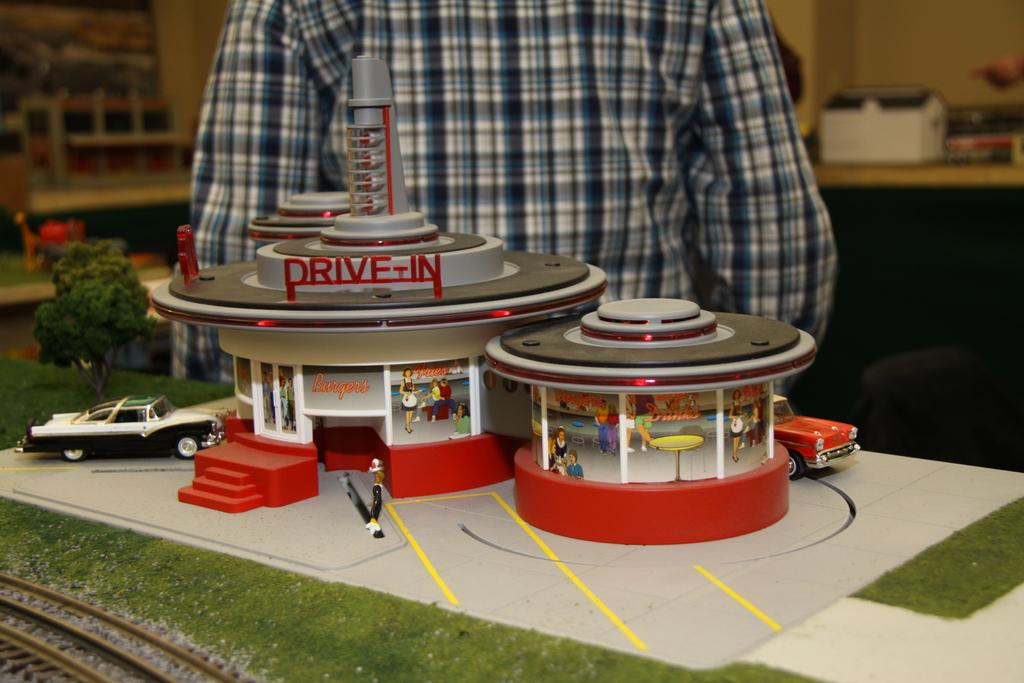<image>
Relay a brief, clear account of the picture shown. a small mural of a drive-in move theatre 